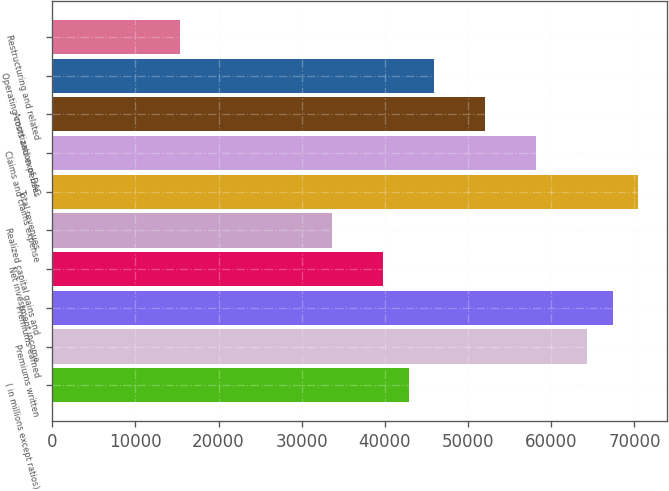Convert chart to OTSL. <chart><loc_0><loc_0><loc_500><loc_500><bar_chart><fcel>( in millions except ratios)<fcel>Premiums written<fcel>Premiums earned<fcel>Net investment income<fcel>Realized capital gains and<fcel>Total revenues<fcel>Claims and claims expense<fcel>Amortization of DAC<fcel>Operating costs and expenses<fcel>Restructuring and related<nl><fcel>42869.4<fcel>64304<fcel>67366.1<fcel>39807.3<fcel>33683.1<fcel>70428.2<fcel>58179.8<fcel>52055.6<fcel>45931.4<fcel>15310.5<nl></chart> 